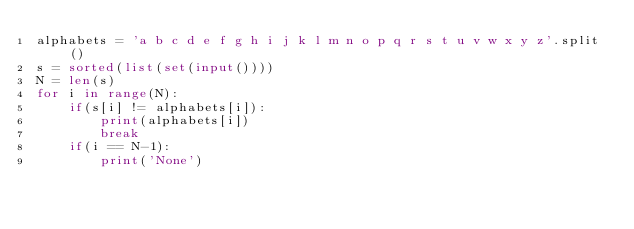<code> <loc_0><loc_0><loc_500><loc_500><_Python_>alphabets = 'a b c d e f g h i j k l m n o p q r s t u v w x y z'.split()
s = sorted(list(set(input())))
N = len(s)
for i in range(N):
    if(s[i] != alphabets[i]):
        print(alphabets[i])
        break
    if(i == N-1):
        print('None')</code> 